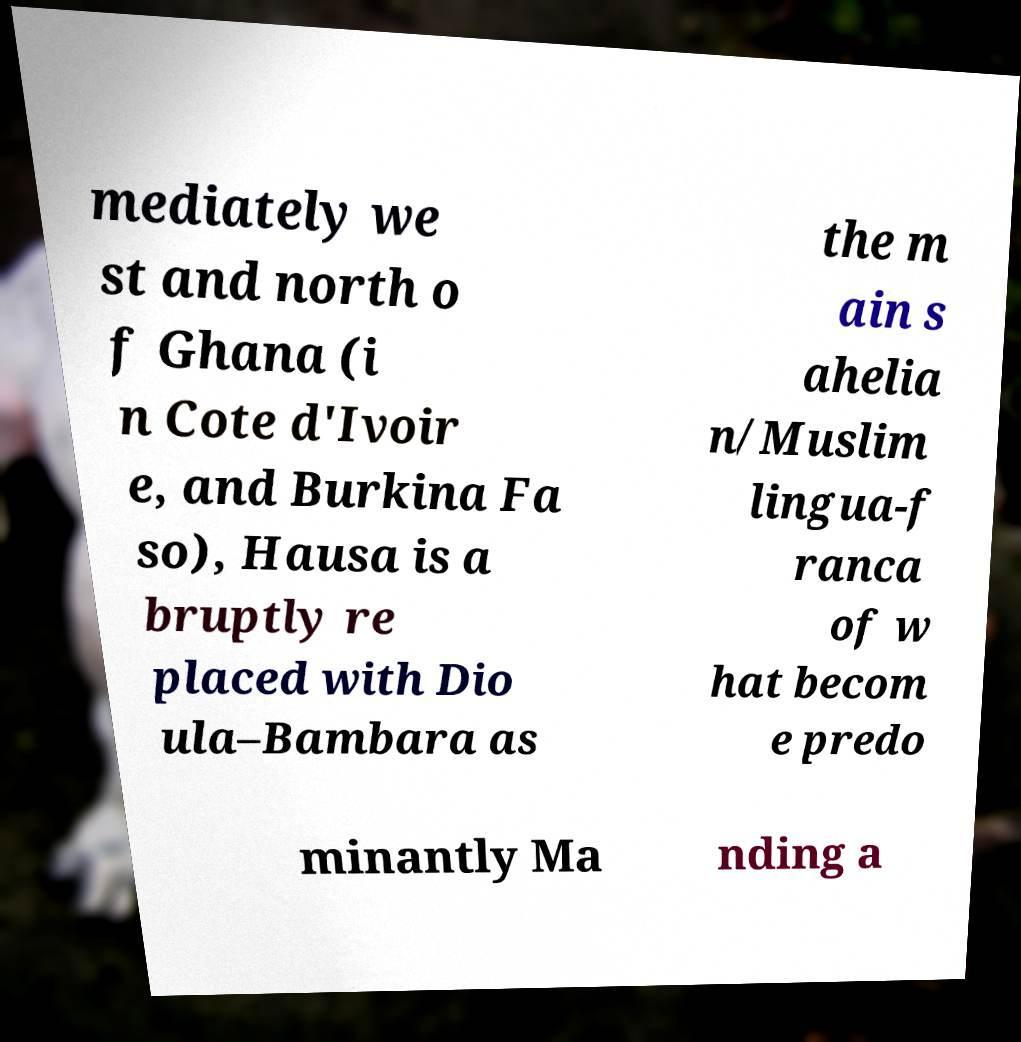Can you read and provide the text displayed in the image?This photo seems to have some interesting text. Can you extract and type it out for me? mediately we st and north o f Ghana (i n Cote d'Ivoir e, and Burkina Fa so), Hausa is a bruptly re placed with Dio ula–Bambara as the m ain s ahelia n/Muslim lingua-f ranca of w hat becom e predo minantly Ma nding a 